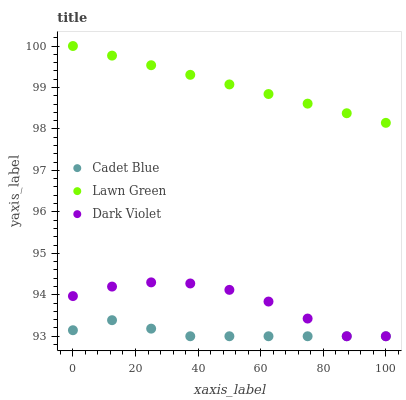Does Cadet Blue have the minimum area under the curve?
Answer yes or no. Yes. Does Lawn Green have the maximum area under the curve?
Answer yes or no. Yes. Does Dark Violet have the minimum area under the curve?
Answer yes or no. No. Does Dark Violet have the maximum area under the curve?
Answer yes or no. No. Is Lawn Green the smoothest?
Answer yes or no. Yes. Is Dark Violet the roughest?
Answer yes or no. Yes. Is Cadet Blue the smoothest?
Answer yes or no. No. Is Cadet Blue the roughest?
Answer yes or no. No. Does Cadet Blue have the lowest value?
Answer yes or no. Yes. Does Lawn Green have the highest value?
Answer yes or no. Yes. Does Dark Violet have the highest value?
Answer yes or no. No. Is Cadet Blue less than Lawn Green?
Answer yes or no. Yes. Is Lawn Green greater than Dark Violet?
Answer yes or no. Yes. Does Cadet Blue intersect Dark Violet?
Answer yes or no. Yes. Is Cadet Blue less than Dark Violet?
Answer yes or no. No. Is Cadet Blue greater than Dark Violet?
Answer yes or no. No. Does Cadet Blue intersect Lawn Green?
Answer yes or no. No. 